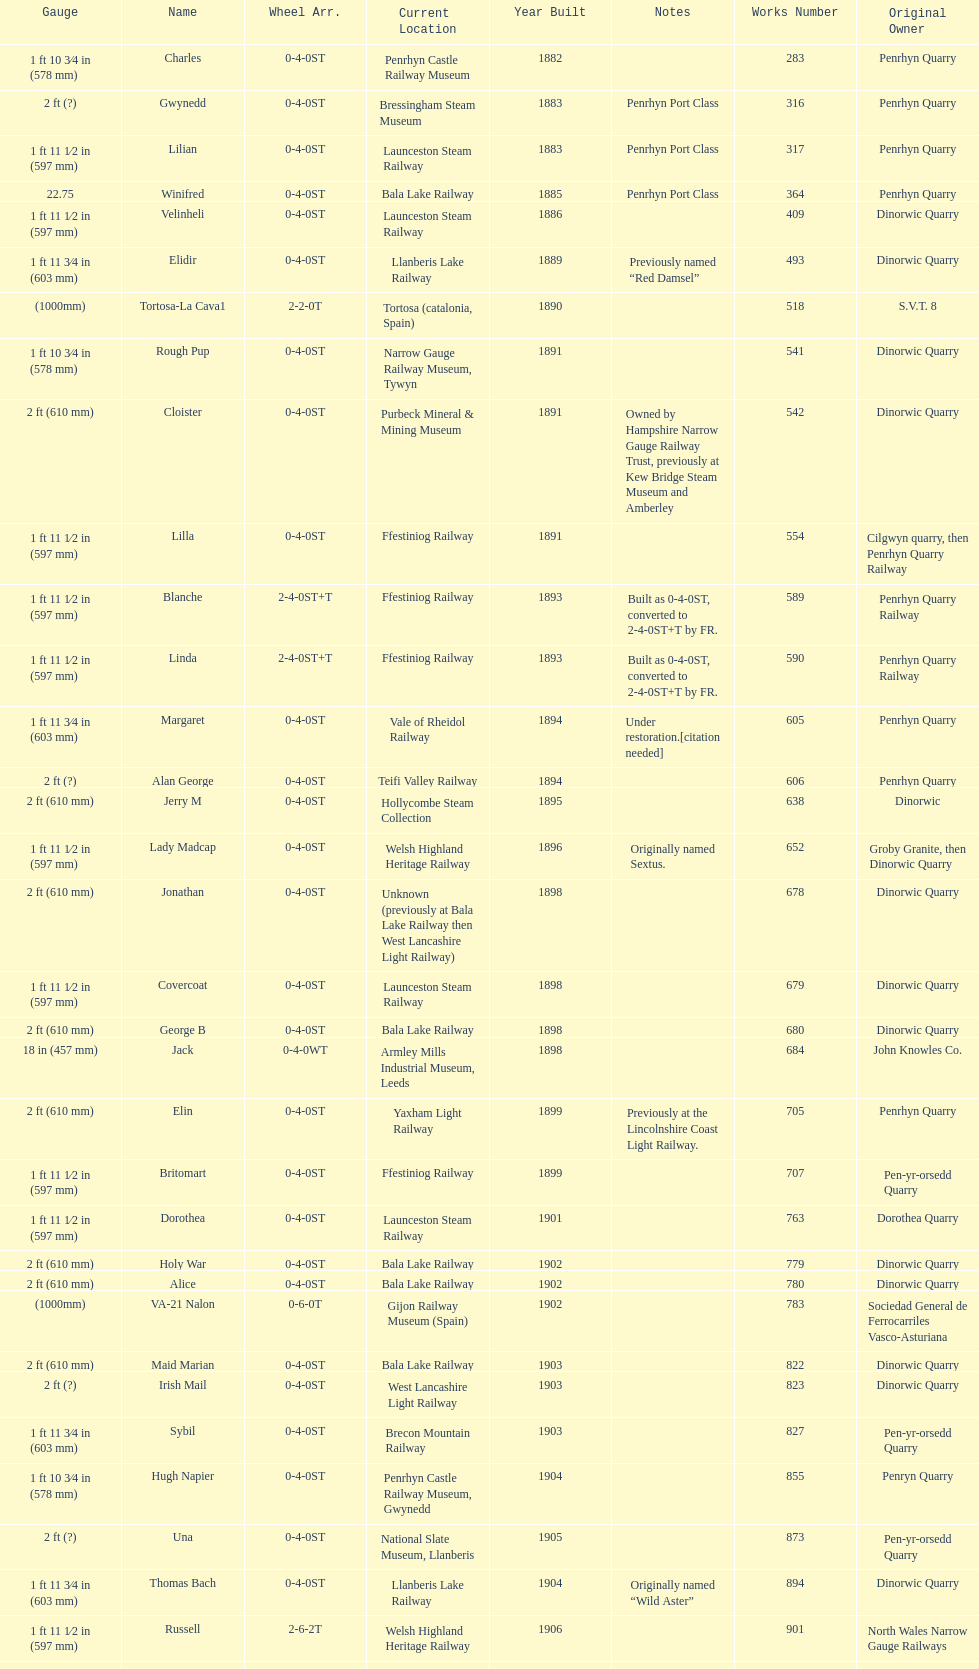Who owned the last locomotive to be built? Trangkil Sugar Mill, Indonesia. 